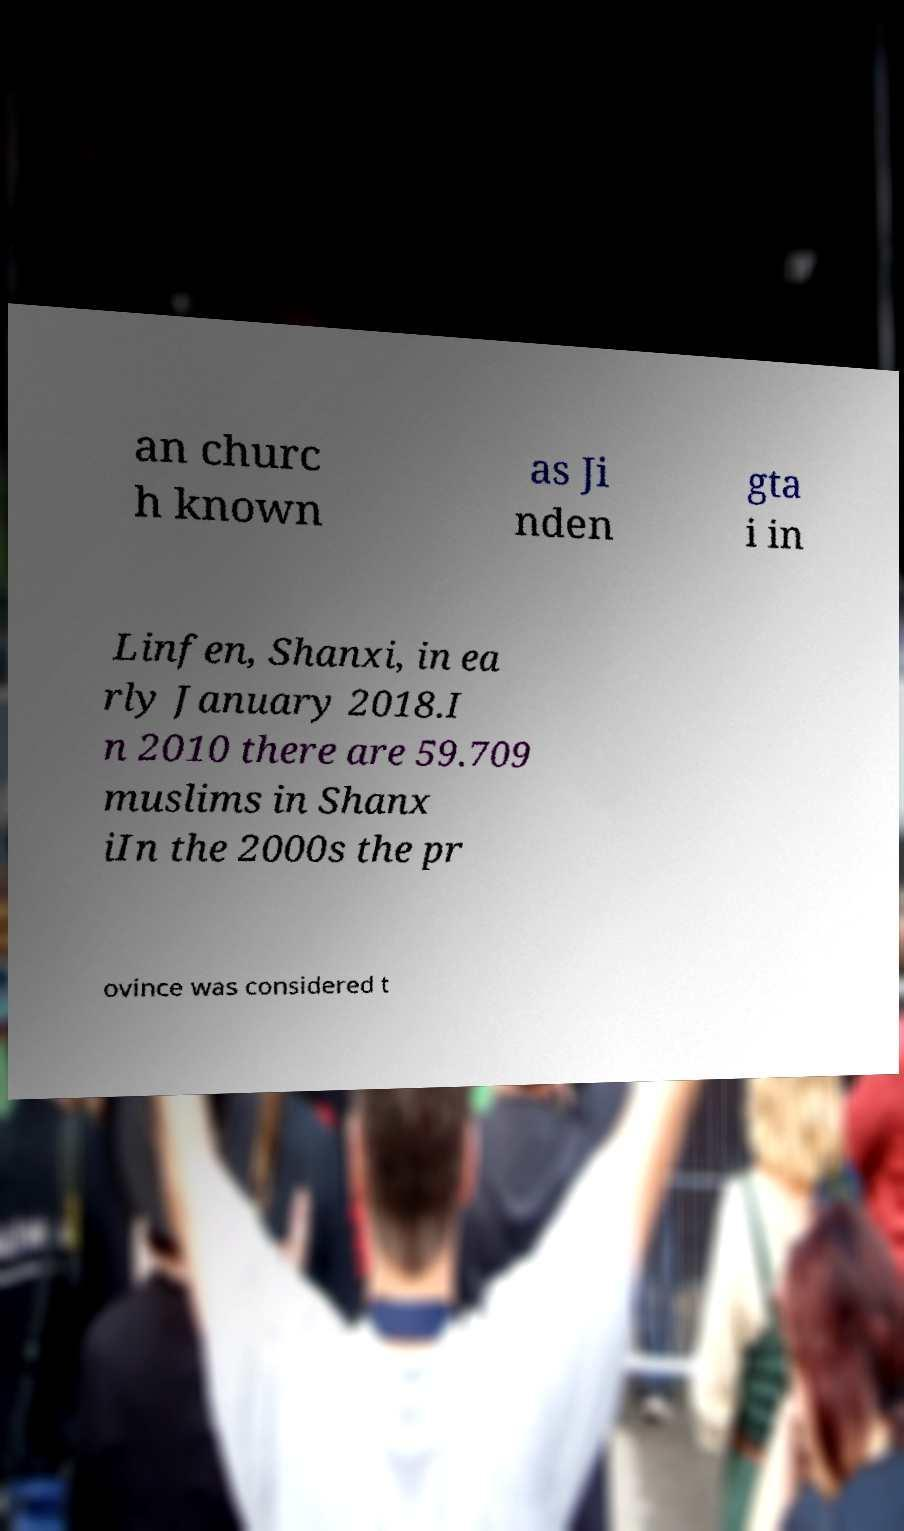For documentation purposes, I need the text within this image transcribed. Could you provide that? an churc h known as Ji nden gta i in Linfen, Shanxi, in ea rly January 2018.I n 2010 there are 59.709 muslims in Shanx iIn the 2000s the pr ovince was considered t 